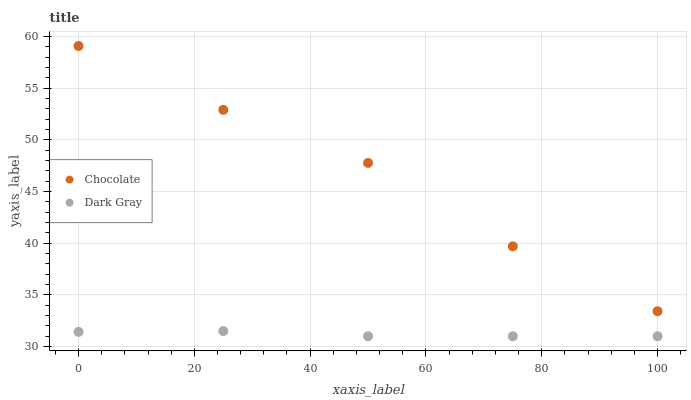Does Dark Gray have the minimum area under the curve?
Answer yes or no. Yes. Does Chocolate have the maximum area under the curve?
Answer yes or no. Yes. Does Chocolate have the minimum area under the curve?
Answer yes or no. No. Is Dark Gray the smoothest?
Answer yes or no. Yes. Is Chocolate the roughest?
Answer yes or no. Yes. Is Chocolate the smoothest?
Answer yes or no. No. Does Dark Gray have the lowest value?
Answer yes or no. Yes. Does Chocolate have the lowest value?
Answer yes or no. No. Does Chocolate have the highest value?
Answer yes or no. Yes. Is Dark Gray less than Chocolate?
Answer yes or no. Yes. Is Chocolate greater than Dark Gray?
Answer yes or no. Yes. Does Dark Gray intersect Chocolate?
Answer yes or no. No. 